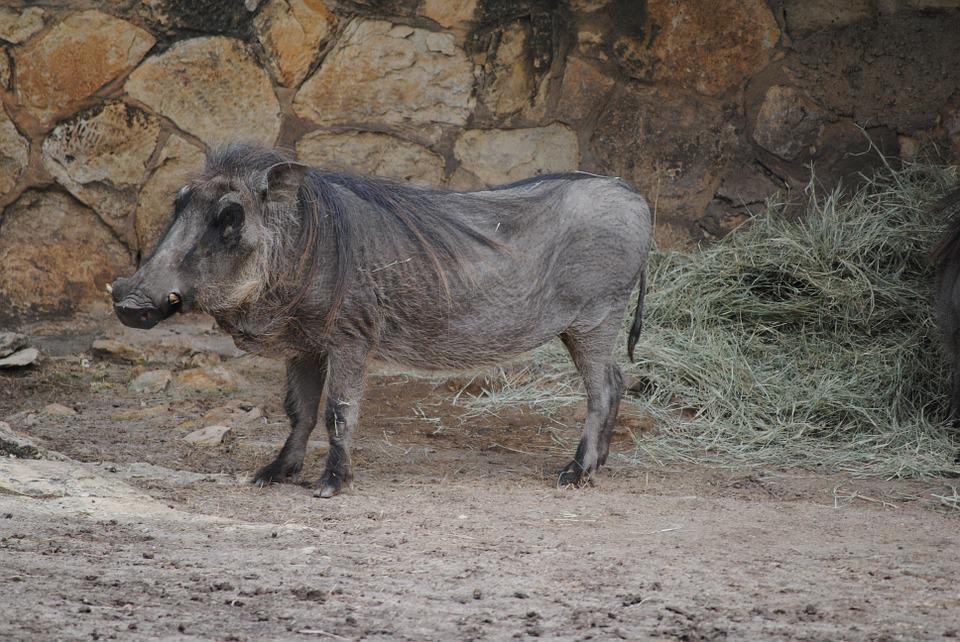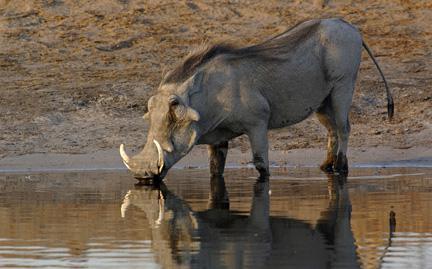The first image is the image on the left, the second image is the image on the right. For the images displayed, is the sentence "There are two animals in the image on the left." factually correct? Answer yes or no. No. 